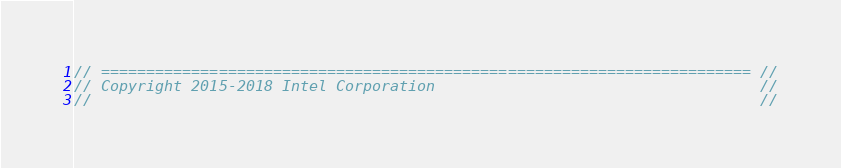<code> <loc_0><loc_0><loc_500><loc_500><_C_>// ======================================================================== //
// Copyright 2015-2018 Intel Corporation                                    //
//                                                                          //</code> 